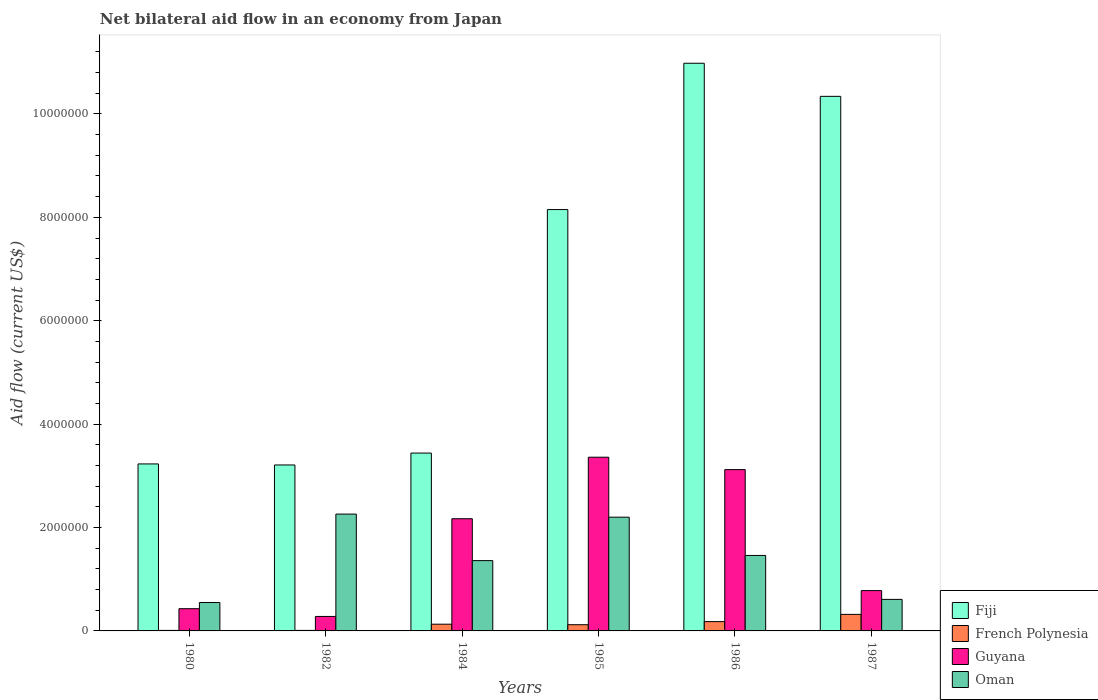How many different coloured bars are there?
Your answer should be very brief. 4. How many groups of bars are there?
Make the answer very short. 6. How many bars are there on the 6th tick from the right?
Your answer should be compact. 4. What is the label of the 1st group of bars from the left?
Keep it short and to the point. 1980. Across all years, what is the maximum net bilateral aid flow in Fiji?
Your response must be concise. 1.10e+07. Across all years, what is the minimum net bilateral aid flow in Oman?
Your answer should be very brief. 5.50e+05. In which year was the net bilateral aid flow in French Polynesia maximum?
Ensure brevity in your answer.  1987. What is the total net bilateral aid flow in Fiji in the graph?
Keep it short and to the point. 3.94e+07. What is the difference between the net bilateral aid flow in Oman in 1980 and that in 1982?
Provide a short and direct response. -1.71e+06. What is the difference between the net bilateral aid flow in Fiji in 1982 and the net bilateral aid flow in Guyana in 1987?
Offer a terse response. 2.43e+06. What is the average net bilateral aid flow in Oman per year?
Your answer should be compact. 1.41e+06. In the year 1982, what is the difference between the net bilateral aid flow in French Polynesia and net bilateral aid flow in Fiji?
Your response must be concise. -3.20e+06. What is the ratio of the net bilateral aid flow in Fiji in 1982 to that in 1987?
Make the answer very short. 0.31. What is the difference between the highest and the second highest net bilateral aid flow in Oman?
Give a very brief answer. 6.00e+04. What is the difference between the highest and the lowest net bilateral aid flow in Fiji?
Offer a very short reply. 7.77e+06. Is the sum of the net bilateral aid flow in French Polynesia in 1985 and 1987 greater than the maximum net bilateral aid flow in Fiji across all years?
Your response must be concise. No. What does the 4th bar from the left in 1986 represents?
Offer a terse response. Oman. What does the 3rd bar from the right in 1980 represents?
Provide a short and direct response. French Polynesia. Are all the bars in the graph horizontal?
Offer a very short reply. No. Does the graph contain any zero values?
Give a very brief answer. No. Does the graph contain grids?
Make the answer very short. No. Where does the legend appear in the graph?
Keep it short and to the point. Bottom right. How many legend labels are there?
Give a very brief answer. 4. What is the title of the graph?
Offer a very short reply. Net bilateral aid flow in an economy from Japan. What is the label or title of the Y-axis?
Make the answer very short. Aid flow (current US$). What is the Aid flow (current US$) of Fiji in 1980?
Make the answer very short. 3.23e+06. What is the Aid flow (current US$) in French Polynesia in 1980?
Your answer should be compact. 10000. What is the Aid flow (current US$) of Guyana in 1980?
Give a very brief answer. 4.30e+05. What is the Aid flow (current US$) of Fiji in 1982?
Provide a short and direct response. 3.21e+06. What is the Aid flow (current US$) of Guyana in 1982?
Ensure brevity in your answer.  2.80e+05. What is the Aid flow (current US$) of Oman in 1982?
Provide a short and direct response. 2.26e+06. What is the Aid flow (current US$) of Fiji in 1984?
Provide a short and direct response. 3.44e+06. What is the Aid flow (current US$) of Guyana in 1984?
Your response must be concise. 2.17e+06. What is the Aid flow (current US$) of Oman in 1984?
Your response must be concise. 1.36e+06. What is the Aid flow (current US$) of Fiji in 1985?
Provide a succinct answer. 8.15e+06. What is the Aid flow (current US$) in Guyana in 1985?
Provide a succinct answer. 3.36e+06. What is the Aid flow (current US$) in Oman in 1985?
Give a very brief answer. 2.20e+06. What is the Aid flow (current US$) in Fiji in 1986?
Your response must be concise. 1.10e+07. What is the Aid flow (current US$) of Guyana in 1986?
Your answer should be very brief. 3.12e+06. What is the Aid flow (current US$) of Oman in 1986?
Provide a short and direct response. 1.46e+06. What is the Aid flow (current US$) in Fiji in 1987?
Keep it short and to the point. 1.03e+07. What is the Aid flow (current US$) in French Polynesia in 1987?
Your answer should be very brief. 3.20e+05. What is the Aid flow (current US$) in Guyana in 1987?
Provide a short and direct response. 7.80e+05. Across all years, what is the maximum Aid flow (current US$) of Fiji?
Offer a terse response. 1.10e+07. Across all years, what is the maximum Aid flow (current US$) of French Polynesia?
Make the answer very short. 3.20e+05. Across all years, what is the maximum Aid flow (current US$) in Guyana?
Give a very brief answer. 3.36e+06. Across all years, what is the maximum Aid flow (current US$) in Oman?
Keep it short and to the point. 2.26e+06. Across all years, what is the minimum Aid flow (current US$) of Fiji?
Ensure brevity in your answer.  3.21e+06. Across all years, what is the minimum Aid flow (current US$) in Guyana?
Your answer should be compact. 2.80e+05. Across all years, what is the minimum Aid flow (current US$) of Oman?
Provide a short and direct response. 5.50e+05. What is the total Aid flow (current US$) in Fiji in the graph?
Give a very brief answer. 3.94e+07. What is the total Aid flow (current US$) in French Polynesia in the graph?
Your answer should be very brief. 7.70e+05. What is the total Aid flow (current US$) in Guyana in the graph?
Provide a short and direct response. 1.01e+07. What is the total Aid flow (current US$) of Oman in the graph?
Your answer should be compact. 8.44e+06. What is the difference between the Aid flow (current US$) of French Polynesia in 1980 and that in 1982?
Your response must be concise. 0. What is the difference between the Aid flow (current US$) in Oman in 1980 and that in 1982?
Give a very brief answer. -1.71e+06. What is the difference between the Aid flow (current US$) in French Polynesia in 1980 and that in 1984?
Make the answer very short. -1.20e+05. What is the difference between the Aid flow (current US$) in Guyana in 1980 and that in 1984?
Ensure brevity in your answer.  -1.74e+06. What is the difference between the Aid flow (current US$) in Oman in 1980 and that in 1984?
Provide a short and direct response. -8.10e+05. What is the difference between the Aid flow (current US$) in Fiji in 1980 and that in 1985?
Your answer should be very brief. -4.92e+06. What is the difference between the Aid flow (current US$) in Guyana in 1980 and that in 1985?
Offer a very short reply. -2.93e+06. What is the difference between the Aid flow (current US$) of Oman in 1980 and that in 1985?
Your answer should be very brief. -1.65e+06. What is the difference between the Aid flow (current US$) of Fiji in 1980 and that in 1986?
Make the answer very short. -7.75e+06. What is the difference between the Aid flow (current US$) of Guyana in 1980 and that in 1986?
Offer a terse response. -2.69e+06. What is the difference between the Aid flow (current US$) in Oman in 1980 and that in 1986?
Provide a short and direct response. -9.10e+05. What is the difference between the Aid flow (current US$) in Fiji in 1980 and that in 1987?
Your answer should be compact. -7.11e+06. What is the difference between the Aid flow (current US$) in French Polynesia in 1980 and that in 1987?
Offer a very short reply. -3.10e+05. What is the difference between the Aid flow (current US$) of Guyana in 1980 and that in 1987?
Give a very brief answer. -3.50e+05. What is the difference between the Aid flow (current US$) in Guyana in 1982 and that in 1984?
Your answer should be very brief. -1.89e+06. What is the difference between the Aid flow (current US$) in Oman in 1982 and that in 1984?
Make the answer very short. 9.00e+05. What is the difference between the Aid flow (current US$) of Fiji in 1982 and that in 1985?
Your response must be concise. -4.94e+06. What is the difference between the Aid flow (current US$) in Guyana in 1982 and that in 1985?
Give a very brief answer. -3.08e+06. What is the difference between the Aid flow (current US$) in Oman in 1982 and that in 1985?
Give a very brief answer. 6.00e+04. What is the difference between the Aid flow (current US$) of Fiji in 1982 and that in 1986?
Your answer should be compact. -7.77e+06. What is the difference between the Aid flow (current US$) of French Polynesia in 1982 and that in 1986?
Offer a very short reply. -1.70e+05. What is the difference between the Aid flow (current US$) in Guyana in 1982 and that in 1986?
Your answer should be compact. -2.84e+06. What is the difference between the Aid flow (current US$) of Oman in 1982 and that in 1986?
Your response must be concise. 8.00e+05. What is the difference between the Aid flow (current US$) of Fiji in 1982 and that in 1987?
Your response must be concise. -7.13e+06. What is the difference between the Aid flow (current US$) of French Polynesia in 1982 and that in 1987?
Offer a terse response. -3.10e+05. What is the difference between the Aid flow (current US$) in Guyana in 1982 and that in 1987?
Give a very brief answer. -5.00e+05. What is the difference between the Aid flow (current US$) of Oman in 1982 and that in 1987?
Offer a terse response. 1.65e+06. What is the difference between the Aid flow (current US$) of Fiji in 1984 and that in 1985?
Make the answer very short. -4.71e+06. What is the difference between the Aid flow (current US$) in French Polynesia in 1984 and that in 1985?
Offer a very short reply. 10000. What is the difference between the Aid flow (current US$) of Guyana in 1984 and that in 1985?
Offer a very short reply. -1.19e+06. What is the difference between the Aid flow (current US$) in Oman in 1984 and that in 1985?
Ensure brevity in your answer.  -8.40e+05. What is the difference between the Aid flow (current US$) in Fiji in 1984 and that in 1986?
Provide a succinct answer. -7.54e+06. What is the difference between the Aid flow (current US$) of Guyana in 1984 and that in 1986?
Ensure brevity in your answer.  -9.50e+05. What is the difference between the Aid flow (current US$) in Oman in 1984 and that in 1986?
Give a very brief answer. -1.00e+05. What is the difference between the Aid flow (current US$) of Fiji in 1984 and that in 1987?
Provide a succinct answer. -6.90e+06. What is the difference between the Aid flow (current US$) in Guyana in 1984 and that in 1987?
Offer a terse response. 1.39e+06. What is the difference between the Aid flow (current US$) in Oman in 1984 and that in 1987?
Provide a succinct answer. 7.50e+05. What is the difference between the Aid flow (current US$) in Fiji in 1985 and that in 1986?
Make the answer very short. -2.83e+06. What is the difference between the Aid flow (current US$) in Guyana in 1985 and that in 1986?
Offer a terse response. 2.40e+05. What is the difference between the Aid flow (current US$) of Oman in 1985 and that in 1986?
Provide a succinct answer. 7.40e+05. What is the difference between the Aid flow (current US$) in Fiji in 1985 and that in 1987?
Give a very brief answer. -2.19e+06. What is the difference between the Aid flow (current US$) in Guyana in 1985 and that in 1987?
Your answer should be very brief. 2.58e+06. What is the difference between the Aid flow (current US$) in Oman in 1985 and that in 1987?
Offer a terse response. 1.59e+06. What is the difference between the Aid flow (current US$) of Fiji in 1986 and that in 1987?
Offer a very short reply. 6.40e+05. What is the difference between the Aid flow (current US$) in French Polynesia in 1986 and that in 1987?
Provide a succinct answer. -1.40e+05. What is the difference between the Aid flow (current US$) in Guyana in 1986 and that in 1987?
Give a very brief answer. 2.34e+06. What is the difference between the Aid flow (current US$) in Oman in 1986 and that in 1987?
Offer a very short reply. 8.50e+05. What is the difference between the Aid flow (current US$) in Fiji in 1980 and the Aid flow (current US$) in French Polynesia in 1982?
Make the answer very short. 3.22e+06. What is the difference between the Aid flow (current US$) of Fiji in 1980 and the Aid flow (current US$) of Guyana in 1982?
Ensure brevity in your answer.  2.95e+06. What is the difference between the Aid flow (current US$) of Fiji in 1980 and the Aid flow (current US$) of Oman in 1982?
Offer a terse response. 9.70e+05. What is the difference between the Aid flow (current US$) in French Polynesia in 1980 and the Aid flow (current US$) in Guyana in 1982?
Provide a succinct answer. -2.70e+05. What is the difference between the Aid flow (current US$) of French Polynesia in 1980 and the Aid flow (current US$) of Oman in 1982?
Your response must be concise. -2.25e+06. What is the difference between the Aid flow (current US$) in Guyana in 1980 and the Aid flow (current US$) in Oman in 1982?
Provide a short and direct response. -1.83e+06. What is the difference between the Aid flow (current US$) of Fiji in 1980 and the Aid flow (current US$) of French Polynesia in 1984?
Offer a very short reply. 3.10e+06. What is the difference between the Aid flow (current US$) of Fiji in 1980 and the Aid flow (current US$) of Guyana in 1984?
Provide a short and direct response. 1.06e+06. What is the difference between the Aid flow (current US$) of Fiji in 1980 and the Aid flow (current US$) of Oman in 1984?
Your answer should be very brief. 1.87e+06. What is the difference between the Aid flow (current US$) of French Polynesia in 1980 and the Aid flow (current US$) of Guyana in 1984?
Offer a terse response. -2.16e+06. What is the difference between the Aid flow (current US$) in French Polynesia in 1980 and the Aid flow (current US$) in Oman in 1984?
Your answer should be compact. -1.35e+06. What is the difference between the Aid flow (current US$) of Guyana in 1980 and the Aid flow (current US$) of Oman in 1984?
Ensure brevity in your answer.  -9.30e+05. What is the difference between the Aid flow (current US$) of Fiji in 1980 and the Aid flow (current US$) of French Polynesia in 1985?
Keep it short and to the point. 3.11e+06. What is the difference between the Aid flow (current US$) in Fiji in 1980 and the Aid flow (current US$) in Guyana in 1985?
Your answer should be compact. -1.30e+05. What is the difference between the Aid flow (current US$) of Fiji in 1980 and the Aid flow (current US$) of Oman in 1985?
Your answer should be compact. 1.03e+06. What is the difference between the Aid flow (current US$) in French Polynesia in 1980 and the Aid flow (current US$) in Guyana in 1985?
Your answer should be very brief. -3.35e+06. What is the difference between the Aid flow (current US$) in French Polynesia in 1980 and the Aid flow (current US$) in Oman in 1985?
Provide a short and direct response. -2.19e+06. What is the difference between the Aid flow (current US$) of Guyana in 1980 and the Aid flow (current US$) of Oman in 1985?
Offer a very short reply. -1.77e+06. What is the difference between the Aid flow (current US$) in Fiji in 1980 and the Aid flow (current US$) in French Polynesia in 1986?
Provide a succinct answer. 3.05e+06. What is the difference between the Aid flow (current US$) in Fiji in 1980 and the Aid flow (current US$) in Oman in 1986?
Ensure brevity in your answer.  1.77e+06. What is the difference between the Aid flow (current US$) of French Polynesia in 1980 and the Aid flow (current US$) of Guyana in 1986?
Keep it short and to the point. -3.11e+06. What is the difference between the Aid flow (current US$) in French Polynesia in 1980 and the Aid flow (current US$) in Oman in 1986?
Offer a terse response. -1.45e+06. What is the difference between the Aid flow (current US$) in Guyana in 1980 and the Aid flow (current US$) in Oman in 1986?
Your response must be concise. -1.03e+06. What is the difference between the Aid flow (current US$) in Fiji in 1980 and the Aid flow (current US$) in French Polynesia in 1987?
Provide a succinct answer. 2.91e+06. What is the difference between the Aid flow (current US$) of Fiji in 1980 and the Aid flow (current US$) of Guyana in 1987?
Offer a very short reply. 2.45e+06. What is the difference between the Aid flow (current US$) of Fiji in 1980 and the Aid flow (current US$) of Oman in 1987?
Make the answer very short. 2.62e+06. What is the difference between the Aid flow (current US$) of French Polynesia in 1980 and the Aid flow (current US$) of Guyana in 1987?
Provide a short and direct response. -7.70e+05. What is the difference between the Aid flow (current US$) in French Polynesia in 1980 and the Aid flow (current US$) in Oman in 1987?
Offer a terse response. -6.00e+05. What is the difference between the Aid flow (current US$) in Guyana in 1980 and the Aid flow (current US$) in Oman in 1987?
Keep it short and to the point. -1.80e+05. What is the difference between the Aid flow (current US$) in Fiji in 1982 and the Aid flow (current US$) in French Polynesia in 1984?
Keep it short and to the point. 3.08e+06. What is the difference between the Aid flow (current US$) of Fiji in 1982 and the Aid flow (current US$) of Guyana in 1984?
Make the answer very short. 1.04e+06. What is the difference between the Aid flow (current US$) of Fiji in 1982 and the Aid flow (current US$) of Oman in 1984?
Offer a terse response. 1.85e+06. What is the difference between the Aid flow (current US$) of French Polynesia in 1982 and the Aid flow (current US$) of Guyana in 1984?
Ensure brevity in your answer.  -2.16e+06. What is the difference between the Aid flow (current US$) of French Polynesia in 1982 and the Aid flow (current US$) of Oman in 1984?
Your response must be concise. -1.35e+06. What is the difference between the Aid flow (current US$) in Guyana in 1982 and the Aid flow (current US$) in Oman in 1984?
Your response must be concise. -1.08e+06. What is the difference between the Aid flow (current US$) in Fiji in 1982 and the Aid flow (current US$) in French Polynesia in 1985?
Keep it short and to the point. 3.09e+06. What is the difference between the Aid flow (current US$) of Fiji in 1982 and the Aid flow (current US$) of Oman in 1985?
Make the answer very short. 1.01e+06. What is the difference between the Aid flow (current US$) in French Polynesia in 1982 and the Aid flow (current US$) in Guyana in 1985?
Make the answer very short. -3.35e+06. What is the difference between the Aid flow (current US$) in French Polynesia in 1982 and the Aid flow (current US$) in Oman in 1985?
Offer a very short reply. -2.19e+06. What is the difference between the Aid flow (current US$) in Guyana in 1982 and the Aid flow (current US$) in Oman in 1985?
Offer a very short reply. -1.92e+06. What is the difference between the Aid flow (current US$) of Fiji in 1982 and the Aid flow (current US$) of French Polynesia in 1986?
Provide a succinct answer. 3.03e+06. What is the difference between the Aid flow (current US$) in Fiji in 1982 and the Aid flow (current US$) in Oman in 1986?
Keep it short and to the point. 1.75e+06. What is the difference between the Aid flow (current US$) of French Polynesia in 1982 and the Aid flow (current US$) of Guyana in 1986?
Ensure brevity in your answer.  -3.11e+06. What is the difference between the Aid flow (current US$) of French Polynesia in 1982 and the Aid flow (current US$) of Oman in 1986?
Provide a succinct answer. -1.45e+06. What is the difference between the Aid flow (current US$) of Guyana in 1982 and the Aid flow (current US$) of Oman in 1986?
Provide a succinct answer. -1.18e+06. What is the difference between the Aid flow (current US$) in Fiji in 1982 and the Aid flow (current US$) in French Polynesia in 1987?
Provide a succinct answer. 2.89e+06. What is the difference between the Aid flow (current US$) in Fiji in 1982 and the Aid flow (current US$) in Guyana in 1987?
Keep it short and to the point. 2.43e+06. What is the difference between the Aid flow (current US$) in Fiji in 1982 and the Aid flow (current US$) in Oman in 1987?
Provide a short and direct response. 2.60e+06. What is the difference between the Aid flow (current US$) of French Polynesia in 1982 and the Aid flow (current US$) of Guyana in 1987?
Keep it short and to the point. -7.70e+05. What is the difference between the Aid flow (current US$) in French Polynesia in 1982 and the Aid flow (current US$) in Oman in 1987?
Your answer should be very brief. -6.00e+05. What is the difference between the Aid flow (current US$) of Guyana in 1982 and the Aid flow (current US$) of Oman in 1987?
Make the answer very short. -3.30e+05. What is the difference between the Aid flow (current US$) in Fiji in 1984 and the Aid flow (current US$) in French Polynesia in 1985?
Your answer should be very brief. 3.32e+06. What is the difference between the Aid flow (current US$) of Fiji in 1984 and the Aid flow (current US$) of Oman in 1985?
Provide a succinct answer. 1.24e+06. What is the difference between the Aid flow (current US$) of French Polynesia in 1984 and the Aid flow (current US$) of Guyana in 1985?
Your response must be concise. -3.23e+06. What is the difference between the Aid flow (current US$) in French Polynesia in 1984 and the Aid flow (current US$) in Oman in 1985?
Your answer should be very brief. -2.07e+06. What is the difference between the Aid flow (current US$) in Fiji in 1984 and the Aid flow (current US$) in French Polynesia in 1986?
Offer a very short reply. 3.26e+06. What is the difference between the Aid flow (current US$) of Fiji in 1984 and the Aid flow (current US$) of Guyana in 1986?
Offer a very short reply. 3.20e+05. What is the difference between the Aid flow (current US$) of Fiji in 1984 and the Aid flow (current US$) of Oman in 1986?
Your answer should be very brief. 1.98e+06. What is the difference between the Aid flow (current US$) of French Polynesia in 1984 and the Aid flow (current US$) of Guyana in 1986?
Offer a terse response. -2.99e+06. What is the difference between the Aid flow (current US$) in French Polynesia in 1984 and the Aid flow (current US$) in Oman in 1986?
Offer a very short reply. -1.33e+06. What is the difference between the Aid flow (current US$) of Guyana in 1984 and the Aid flow (current US$) of Oman in 1986?
Offer a terse response. 7.10e+05. What is the difference between the Aid flow (current US$) in Fiji in 1984 and the Aid flow (current US$) in French Polynesia in 1987?
Your answer should be very brief. 3.12e+06. What is the difference between the Aid flow (current US$) in Fiji in 1984 and the Aid flow (current US$) in Guyana in 1987?
Make the answer very short. 2.66e+06. What is the difference between the Aid flow (current US$) in Fiji in 1984 and the Aid flow (current US$) in Oman in 1987?
Keep it short and to the point. 2.83e+06. What is the difference between the Aid flow (current US$) in French Polynesia in 1984 and the Aid flow (current US$) in Guyana in 1987?
Keep it short and to the point. -6.50e+05. What is the difference between the Aid flow (current US$) of French Polynesia in 1984 and the Aid flow (current US$) of Oman in 1987?
Ensure brevity in your answer.  -4.80e+05. What is the difference between the Aid flow (current US$) of Guyana in 1984 and the Aid flow (current US$) of Oman in 1987?
Keep it short and to the point. 1.56e+06. What is the difference between the Aid flow (current US$) in Fiji in 1985 and the Aid flow (current US$) in French Polynesia in 1986?
Your answer should be compact. 7.97e+06. What is the difference between the Aid flow (current US$) in Fiji in 1985 and the Aid flow (current US$) in Guyana in 1986?
Your response must be concise. 5.03e+06. What is the difference between the Aid flow (current US$) in Fiji in 1985 and the Aid flow (current US$) in Oman in 1986?
Make the answer very short. 6.69e+06. What is the difference between the Aid flow (current US$) in French Polynesia in 1985 and the Aid flow (current US$) in Guyana in 1986?
Your answer should be compact. -3.00e+06. What is the difference between the Aid flow (current US$) in French Polynesia in 1985 and the Aid flow (current US$) in Oman in 1986?
Your response must be concise. -1.34e+06. What is the difference between the Aid flow (current US$) of Guyana in 1985 and the Aid flow (current US$) of Oman in 1986?
Ensure brevity in your answer.  1.90e+06. What is the difference between the Aid flow (current US$) of Fiji in 1985 and the Aid flow (current US$) of French Polynesia in 1987?
Provide a short and direct response. 7.83e+06. What is the difference between the Aid flow (current US$) in Fiji in 1985 and the Aid flow (current US$) in Guyana in 1987?
Offer a terse response. 7.37e+06. What is the difference between the Aid flow (current US$) of Fiji in 1985 and the Aid flow (current US$) of Oman in 1987?
Your answer should be compact. 7.54e+06. What is the difference between the Aid flow (current US$) of French Polynesia in 1985 and the Aid flow (current US$) of Guyana in 1987?
Offer a terse response. -6.60e+05. What is the difference between the Aid flow (current US$) of French Polynesia in 1985 and the Aid flow (current US$) of Oman in 1987?
Ensure brevity in your answer.  -4.90e+05. What is the difference between the Aid flow (current US$) of Guyana in 1985 and the Aid flow (current US$) of Oman in 1987?
Your answer should be very brief. 2.75e+06. What is the difference between the Aid flow (current US$) in Fiji in 1986 and the Aid flow (current US$) in French Polynesia in 1987?
Your answer should be very brief. 1.07e+07. What is the difference between the Aid flow (current US$) of Fiji in 1986 and the Aid flow (current US$) of Guyana in 1987?
Make the answer very short. 1.02e+07. What is the difference between the Aid flow (current US$) of Fiji in 1986 and the Aid flow (current US$) of Oman in 1987?
Your response must be concise. 1.04e+07. What is the difference between the Aid flow (current US$) in French Polynesia in 1986 and the Aid flow (current US$) in Guyana in 1987?
Provide a short and direct response. -6.00e+05. What is the difference between the Aid flow (current US$) in French Polynesia in 1986 and the Aid flow (current US$) in Oman in 1987?
Offer a terse response. -4.30e+05. What is the difference between the Aid flow (current US$) of Guyana in 1986 and the Aid flow (current US$) of Oman in 1987?
Offer a very short reply. 2.51e+06. What is the average Aid flow (current US$) in Fiji per year?
Offer a very short reply. 6.56e+06. What is the average Aid flow (current US$) of French Polynesia per year?
Give a very brief answer. 1.28e+05. What is the average Aid flow (current US$) in Guyana per year?
Provide a succinct answer. 1.69e+06. What is the average Aid flow (current US$) in Oman per year?
Make the answer very short. 1.41e+06. In the year 1980, what is the difference between the Aid flow (current US$) in Fiji and Aid flow (current US$) in French Polynesia?
Provide a succinct answer. 3.22e+06. In the year 1980, what is the difference between the Aid flow (current US$) in Fiji and Aid flow (current US$) in Guyana?
Keep it short and to the point. 2.80e+06. In the year 1980, what is the difference between the Aid flow (current US$) of Fiji and Aid flow (current US$) of Oman?
Offer a very short reply. 2.68e+06. In the year 1980, what is the difference between the Aid flow (current US$) of French Polynesia and Aid flow (current US$) of Guyana?
Make the answer very short. -4.20e+05. In the year 1980, what is the difference between the Aid flow (current US$) in French Polynesia and Aid flow (current US$) in Oman?
Provide a succinct answer. -5.40e+05. In the year 1980, what is the difference between the Aid flow (current US$) in Guyana and Aid flow (current US$) in Oman?
Make the answer very short. -1.20e+05. In the year 1982, what is the difference between the Aid flow (current US$) in Fiji and Aid flow (current US$) in French Polynesia?
Your answer should be compact. 3.20e+06. In the year 1982, what is the difference between the Aid flow (current US$) of Fiji and Aid flow (current US$) of Guyana?
Your answer should be compact. 2.93e+06. In the year 1982, what is the difference between the Aid flow (current US$) in Fiji and Aid flow (current US$) in Oman?
Ensure brevity in your answer.  9.50e+05. In the year 1982, what is the difference between the Aid flow (current US$) of French Polynesia and Aid flow (current US$) of Oman?
Keep it short and to the point. -2.25e+06. In the year 1982, what is the difference between the Aid flow (current US$) in Guyana and Aid flow (current US$) in Oman?
Ensure brevity in your answer.  -1.98e+06. In the year 1984, what is the difference between the Aid flow (current US$) of Fiji and Aid flow (current US$) of French Polynesia?
Provide a short and direct response. 3.31e+06. In the year 1984, what is the difference between the Aid flow (current US$) of Fiji and Aid flow (current US$) of Guyana?
Your answer should be very brief. 1.27e+06. In the year 1984, what is the difference between the Aid flow (current US$) of Fiji and Aid flow (current US$) of Oman?
Your answer should be compact. 2.08e+06. In the year 1984, what is the difference between the Aid flow (current US$) in French Polynesia and Aid flow (current US$) in Guyana?
Give a very brief answer. -2.04e+06. In the year 1984, what is the difference between the Aid flow (current US$) of French Polynesia and Aid flow (current US$) of Oman?
Make the answer very short. -1.23e+06. In the year 1984, what is the difference between the Aid flow (current US$) in Guyana and Aid flow (current US$) in Oman?
Offer a very short reply. 8.10e+05. In the year 1985, what is the difference between the Aid flow (current US$) of Fiji and Aid flow (current US$) of French Polynesia?
Your answer should be very brief. 8.03e+06. In the year 1985, what is the difference between the Aid flow (current US$) of Fiji and Aid flow (current US$) of Guyana?
Keep it short and to the point. 4.79e+06. In the year 1985, what is the difference between the Aid flow (current US$) in Fiji and Aid flow (current US$) in Oman?
Offer a terse response. 5.95e+06. In the year 1985, what is the difference between the Aid flow (current US$) in French Polynesia and Aid flow (current US$) in Guyana?
Your answer should be compact. -3.24e+06. In the year 1985, what is the difference between the Aid flow (current US$) of French Polynesia and Aid flow (current US$) of Oman?
Provide a succinct answer. -2.08e+06. In the year 1985, what is the difference between the Aid flow (current US$) of Guyana and Aid flow (current US$) of Oman?
Ensure brevity in your answer.  1.16e+06. In the year 1986, what is the difference between the Aid flow (current US$) of Fiji and Aid flow (current US$) of French Polynesia?
Make the answer very short. 1.08e+07. In the year 1986, what is the difference between the Aid flow (current US$) in Fiji and Aid flow (current US$) in Guyana?
Keep it short and to the point. 7.86e+06. In the year 1986, what is the difference between the Aid flow (current US$) in Fiji and Aid flow (current US$) in Oman?
Your answer should be compact. 9.52e+06. In the year 1986, what is the difference between the Aid flow (current US$) in French Polynesia and Aid flow (current US$) in Guyana?
Your response must be concise. -2.94e+06. In the year 1986, what is the difference between the Aid flow (current US$) in French Polynesia and Aid flow (current US$) in Oman?
Your answer should be very brief. -1.28e+06. In the year 1986, what is the difference between the Aid flow (current US$) in Guyana and Aid flow (current US$) in Oman?
Provide a succinct answer. 1.66e+06. In the year 1987, what is the difference between the Aid flow (current US$) in Fiji and Aid flow (current US$) in French Polynesia?
Ensure brevity in your answer.  1.00e+07. In the year 1987, what is the difference between the Aid flow (current US$) of Fiji and Aid flow (current US$) of Guyana?
Keep it short and to the point. 9.56e+06. In the year 1987, what is the difference between the Aid flow (current US$) of Fiji and Aid flow (current US$) of Oman?
Provide a succinct answer. 9.73e+06. In the year 1987, what is the difference between the Aid flow (current US$) in French Polynesia and Aid flow (current US$) in Guyana?
Your answer should be very brief. -4.60e+05. In the year 1987, what is the difference between the Aid flow (current US$) in French Polynesia and Aid flow (current US$) in Oman?
Your answer should be very brief. -2.90e+05. What is the ratio of the Aid flow (current US$) of Fiji in 1980 to that in 1982?
Provide a succinct answer. 1.01. What is the ratio of the Aid flow (current US$) of French Polynesia in 1980 to that in 1982?
Provide a short and direct response. 1. What is the ratio of the Aid flow (current US$) of Guyana in 1980 to that in 1982?
Your response must be concise. 1.54. What is the ratio of the Aid flow (current US$) in Oman in 1980 to that in 1982?
Your response must be concise. 0.24. What is the ratio of the Aid flow (current US$) of Fiji in 1980 to that in 1984?
Your answer should be compact. 0.94. What is the ratio of the Aid flow (current US$) in French Polynesia in 1980 to that in 1984?
Provide a succinct answer. 0.08. What is the ratio of the Aid flow (current US$) in Guyana in 1980 to that in 1984?
Offer a very short reply. 0.2. What is the ratio of the Aid flow (current US$) of Oman in 1980 to that in 1984?
Make the answer very short. 0.4. What is the ratio of the Aid flow (current US$) in Fiji in 1980 to that in 1985?
Provide a succinct answer. 0.4. What is the ratio of the Aid flow (current US$) in French Polynesia in 1980 to that in 1985?
Keep it short and to the point. 0.08. What is the ratio of the Aid flow (current US$) in Guyana in 1980 to that in 1985?
Provide a short and direct response. 0.13. What is the ratio of the Aid flow (current US$) of Oman in 1980 to that in 1985?
Your answer should be compact. 0.25. What is the ratio of the Aid flow (current US$) of Fiji in 1980 to that in 1986?
Keep it short and to the point. 0.29. What is the ratio of the Aid flow (current US$) of French Polynesia in 1980 to that in 1986?
Give a very brief answer. 0.06. What is the ratio of the Aid flow (current US$) of Guyana in 1980 to that in 1986?
Provide a succinct answer. 0.14. What is the ratio of the Aid flow (current US$) in Oman in 1980 to that in 1986?
Give a very brief answer. 0.38. What is the ratio of the Aid flow (current US$) of Fiji in 1980 to that in 1987?
Make the answer very short. 0.31. What is the ratio of the Aid flow (current US$) of French Polynesia in 1980 to that in 1987?
Provide a succinct answer. 0.03. What is the ratio of the Aid flow (current US$) in Guyana in 1980 to that in 1987?
Your answer should be compact. 0.55. What is the ratio of the Aid flow (current US$) of Oman in 1980 to that in 1987?
Provide a short and direct response. 0.9. What is the ratio of the Aid flow (current US$) of Fiji in 1982 to that in 1984?
Your answer should be compact. 0.93. What is the ratio of the Aid flow (current US$) of French Polynesia in 1982 to that in 1984?
Your answer should be very brief. 0.08. What is the ratio of the Aid flow (current US$) in Guyana in 1982 to that in 1984?
Provide a short and direct response. 0.13. What is the ratio of the Aid flow (current US$) in Oman in 1982 to that in 1984?
Offer a very short reply. 1.66. What is the ratio of the Aid flow (current US$) of Fiji in 1982 to that in 1985?
Keep it short and to the point. 0.39. What is the ratio of the Aid flow (current US$) in French Polynesia in 1982 to that in 1985?
Keep it short and to the point. 0.08. What is the ratio of the Aid flow (current US$) of Guyana in 1982 to that in 1985?
Your answer should be compact. 0.08. What is the ratio of the Aid flow (current US$) of Oman in 1982 to that in 1985?
Your answer should be compact. 1.03. What is the ratio of the Aid flow (current US$) in Fiji in 1982 to that in 1986?
Offer a very short reply. 0.29. What is the ratio of the Aid flow (current US$) in French Polynesia in 1982 to that in 1986?
Make the answer very short. 0.06. What is the ratio of the Aid flow (current US$) in Guyana in 1982 to that in 1986?
Keep it short and to the point. 0.09. What is the ratio of the Aid flow (current US$) of Oman in 1982 to that in 1986?
Your response must be concise. 1.55. What is the ratio of the Aid flow (current US$) in Fiji in 1982 to that in 1987?
Offer a very short reply. 0.31. What is the ratio of the Aid flow (current US$) of French Polynesia in 1982 to that in 1987?
Your response must be concise. 0.03. What is the ratio of the Aid flow (current US$) of Guyana in 1982 to that in 1987?
Offer a very short reply. 0.36. What is the ratio of the Aid flow (current US$) of Oman in 1982 to that in 1987?
Your answer should be very brief. 3.7. What is the ratio of the Aid flow (current US$) of Fiji in 1984 to that in 1985?
Keep it short and to the point. 0.42. What is the ratio of the Aid flow (current US$) in Guyana in 1984 to that in 1985?
Ensure brevity in your answer.  0.65. What is the ratio of the Aid flow (current US$) in Oman in 1984 to that in 1985?
Provide a succinct answer. 0.62. What is the ratio of the Aid flow (current US$) in Fiji in 1984 to that in 1986?
Your answer should be very brief. 0.31. What is the ratio of the Aid flow (current US$) of French Polynesia in 1984 to that in 1986?
Keep it short and to the point. 0.72. What is the ratio of the Aid flow (current US$) in Guyana in 1984 to that in 1986?
Offer a terse response. 0.7. What is the ratio of the Aid flow (current US$) in Oman in 1984 to that in 1986?
Your answer should be very brief. 0.93. What is the ratio of the Aid flow (current US$) of Fiji in 1984 to that in 1987?
Your answer should be compact. 0.33. What is the ratio of the Aid flow (current US$) of French Polynesia in 1984 to that in 1987?
Make the answer very short. 0.41. What is the ratio of the Aid flow (current US$) in Guyana in 1984 to that in 1987?
Your response must be concise. 2.78. What is the ratio of the Aid flow (current US$) in Oman in 1984 to that in 1987?
Keep it short and to the point. 2.23. What is the ratio of the Aid flow (current US$) of Fiji in 1985 to that in 1986?
Give a very brief answer. 0.74. What is the ratio of the Aid flow (current US$) in Guyana in 1985 to that in 1986?
Provide a succinct answer. 1.08. What is the ratio of the Aid flow (current US$) of Oman in 1985 to that in 1986?
Provide a succinct answer. 1.51. What is the ratio of the Aid flow (current US$) of Fiji in 1985 to that in 1987?
Keep it short and to the point. 0.79. What is the ratio of the Aid flow (current US$) in French Polynesia in 1985 to that in 1987?
Offer a terse response. 0.38. What is the ratio of the Aid flow (current US$) in Guyana in 1985 to that in 1987?
Provide a succinct answer. 4.31. What is the ratio of the Aid flow (current US$) of Oman in 1985 to that in 1987?
Make the answer very short. 3.61. What is the ratio of the Aid flow (current US$) in Fiji in 1986 to that in 1987?
Ensure brevity in your answer.  1.06. What is the ratio of the Aid flow (current US$) of French Polynesia in 1986 to that in 1987?
Your answer should be very brief. 0.56. What is the ratio of the Aid flow (current US$) in Guyana in 1986 to that in 1987?
Ensure brevity in your answer.  4. What is the ratio of the Aid flow (current US$) in Oman in 1986 to that in 1987?
Your answer should be very brief. 2.39. What is the difference between the highest and the second highest Aid flow (current US$) of Fiji?
Ensure brevity in your answer.  6.40e+05. What is the difference between the highest and the lowest Aid flow (current US$) of Fiji?
Your answer should be compact. 7.77e+06. What is the difference between the highest and the lowest Aid flow (current US$) in Guyana?
Give a very brief answer. 3.08e+06. What is the difference between the highest and the lowest Aid flow (current US$) of Oman?
Give a very brief answer. 1.71e+06. 